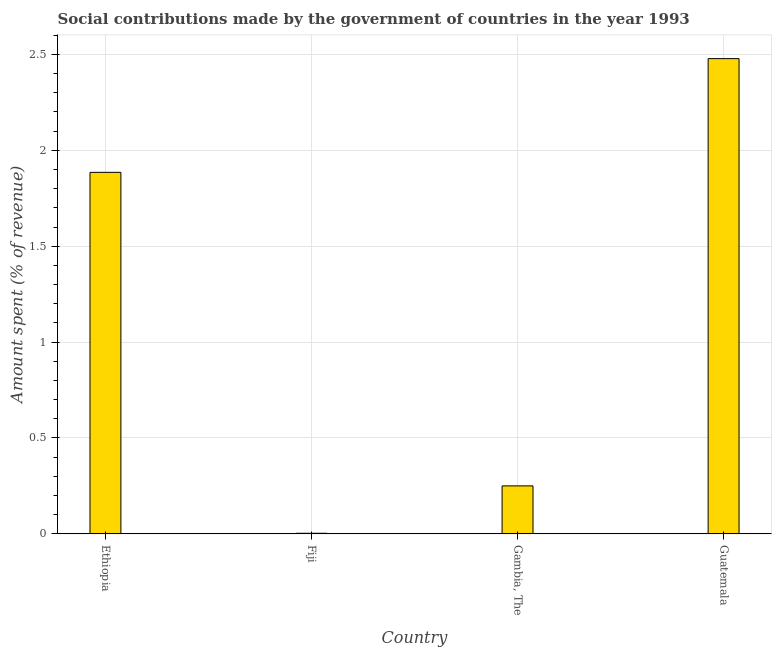Does the graph contain any zero values?
Ensure brevity in your answer.  No. What is the title of the graph?
Provide a short and direct response. Social contributions made by the government of countries in the year 1993. What is the label or title of the X-axis?
Offer a terse response. Country. What is the label or title of the Y-axis?
Provide a short and direct response. Amount spent (% of revenue). What is the amount spent in making social contributions in Gambia, The?
Your answer should be compact. 0.25. Across all countries, what is the maximum amount spent in making social contributions?
Your response must be concise. 2.48. Across all countries, what is the minimum amount spent in making social contributions?
Give a very brief answer. 0. In which country was the amount spent in making social contributions maximum?
Offer a terse response. Guatemala. In which country was the amount spent in making social contributions minimum?
Make the answer very short. Fiji. What is the sum of the amount spent in making social contributions?
Keep it short and to the point. 4.62. What is the difference between the amount spent in making social contributions in Fiji and Guatemala?
Give a very brief answer. -2.48. What is the average amount spent in making social contributions per country?
Offer a very short reply. 1.15. What is the median amount spent in making social contributions?
Your answer should be very brief. 1.07. In how many countries, is the amount spent in making social contributions greater than 1.7 %?
Give a very brief answer. 2. What is the ratio of the amount spent in making social contributions in Fiji to that in Gambia, The?
Offer a very short reply. 0.01. Is the amount spent in making social contributions in Ethiopia less than that in Guatemala?
Your answer should be compact. Yes. What is the difference between the highest and the second highest amount spent in making social contributions?
Your response must be concise. 0.59. What is the difference between the highest and the lowest amount spent in making social contributions?
Your response must be concise. 2.48. In how many countries, is the amount spent in making social contributions greater than the average amount spent in making social contributions taken over all countries?
Your answer should be very brief. 2. Are the values on the major ticks of Y-axis written in scientific E-notation?
Your response must be concise. No. What is the Amount spent (% of revenue) of Ethiopia?
Provide a short and direct response. 1.89. What is the Amount spent (% of revenue) in Fiji?
Offer a terse response. 0. What is the Amount spent (% of revenue) in Gambia, The?
Your response must be concise. 0.25. What is the Amount spent (% of revenue) in Guatemala?
Offer a very short reply. 2.48. What is the difference between the Amount spent (% of revenue) in Ethiopia and Fiji?
Provide a short and direct response. 1.88. What is the difference between the Amount spent (% of revenue) in Ethiopia and Gambia, The?
Your answer should be very brief. 1.63. What is the difference between the Amount spent (% of revenue) in Ethiopia and Guatemala?
Offer a very short reply. -0.59. What is the difference between the Amount spent (% of revenue) in Fiji and Gambia, The?
Your response must be concise. -0.25. What is the difference between the Amount spent (% of revenue) in Fiji and Guatemala?
Your answer should be compact. -2.48. What is the difference between the Amount spent (% of revenue) in Gambia, The and Guatemala?
Keep it short and to the point. -2.23. What is the ratio of the Amount spent (% of revenue) in Ethiopia to that in Fiji?
Give a very brief answer. 607.44. What is the ratio of the Amount spent (% of revenue) in Ethiopia to that in Gambia, The?
Make the answer very short. 7.54. What is the ratio of the Amount spent (% of revenue) in Ethiopia to that in Guatemala?
Your answer should be very brief. 0.76. What is the ratio of the Amount spent (% of revenue) in Fiji to that in Gambia, The?
Your answer should be very brief. 0.01. What is the ratio of the Amount spent (% of revenue) in Fiji to that in Guatemala?
Provide a short and direct response. 0. What is the ratio of the Amount spent (% of revenue) in Gambia, The to that in Guatemala?
Give a very brief answer. 0.1. 